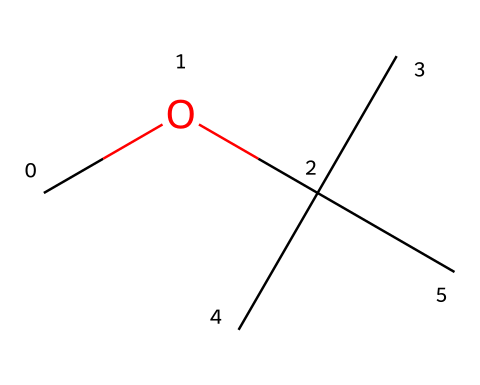What is the chemical name of the compound represented by this SMILES? The SMILES code "COC(C)(C)C" corresponds to a compound known as methyl tert-butyl ether, as indicated by the functional groups and overall structure.
Answer: methyl tert-butyl ether How many carbon atoms are present in this chemical structure? By examining the SMILES code, we can identify five carbon atoms (C) present in the entire molecule.
Answer: 5 What type of functional group is present in methyl tert-butyl ether? The chemical structure contains an ether functional group, characterized by the "C-O-C" arrangement found in ethers.
Answer: ether What is the degree of branching in the carbon chain of this compound? The structure displays significant branching due to the tert-butyl group (C(C)(C)C) that is bonded to the oxygen atom, indicating high branching.
Answer: high How many hydrogen atoms are associated with this molecule? The number of hydrogen atoms can be counted based on the structure, yielding 12 hydrogen atoms total in methyl tert-butyl ether (C4H9 + CH3).
Answer: 12 Is this chemical polar or non-polar? Given the presence of the ether group and the overall structure, which is symmetrical, the compound is relatively non-polar despite having polar bonds.
Answer: non-polar 